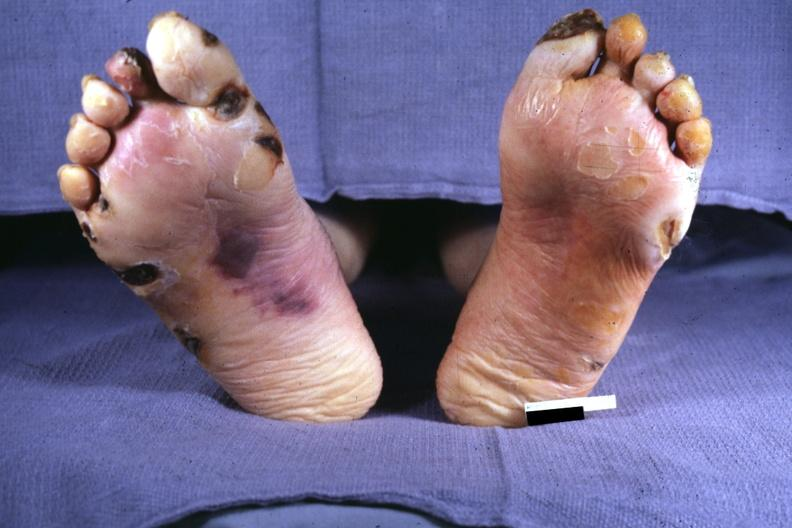what are present?
Answer the question using a single word or phrase. Extremities 